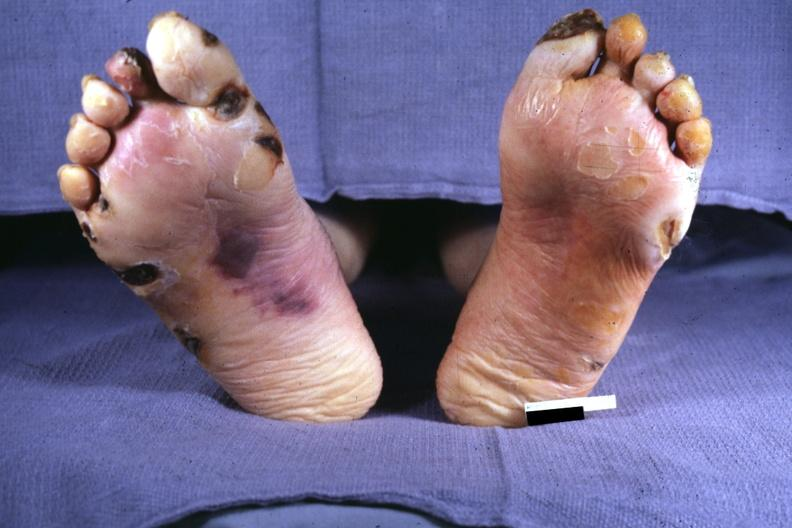what are present?
Answer the question using a single word or phrase. Extremities 